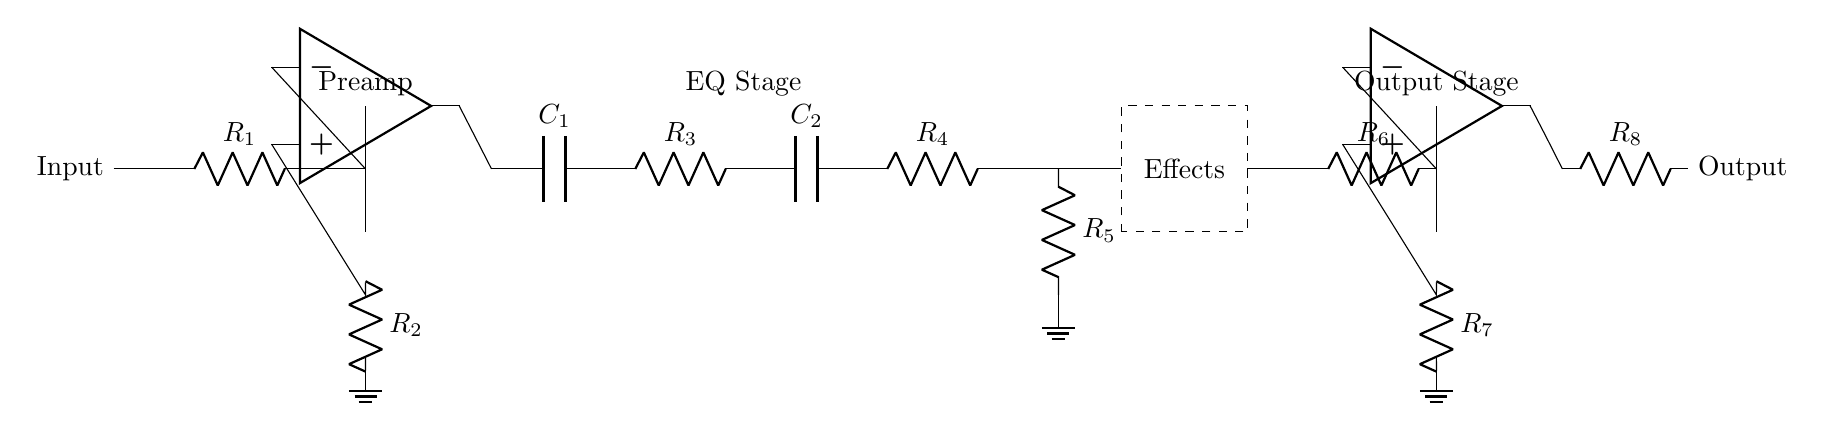What is the first component in the circuit? The first component is a resistor, labeled as R1, which connects from the input to the preamp stage.
Answer: R1 How many operational amplifiers are present? There are two operational amplifiers in the circuit, one in the preamp stage and one in the output stage.
Answer: 2 What type of component is used in the effects loop? The effects loop contains a dashed rectangle labeled 'Effects', which indicates a section for various effects devices or modules.
Answer: Effects What does R2 connect to in the circuit? R2 connects from the output of the preamp (the operational amplifier) down to ground, forming part of the feedback loop for the operational amplifier.
Answer: Ground Which stage comes after the preamp stage? The EQ stage immediately follows the preamp stage in the circuit, carrying the processed signal through capacitors and resistors for equalization.
Answer: EQ Stage Why might capacitors be used in this circuit? Capacitors are used to manage frequency response by filtering signals, allowing for specific tonal shaping in the EQ stage of the circuit.
Answer: Frequency response What component is used to filter the output stage? The output stage uses a resistor labeled R8, which helps to limit the output signal level before it is sent out.
Answer: R8 